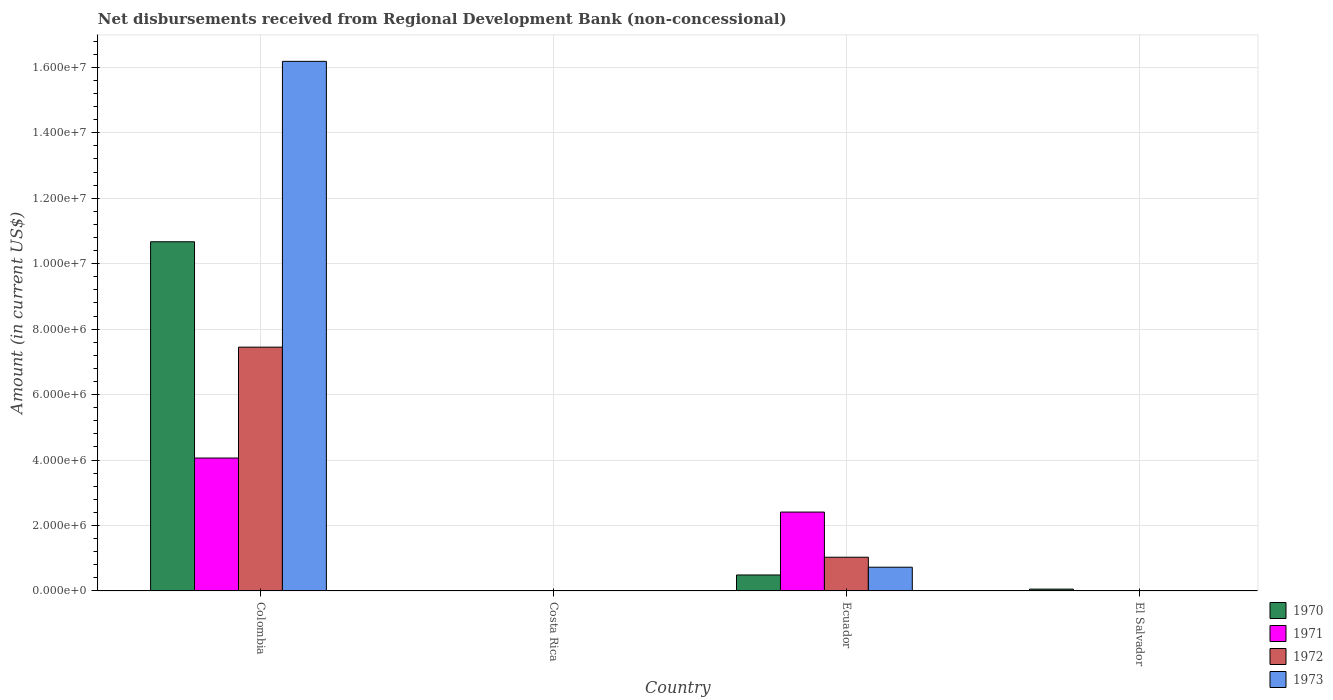How many different coloured bars are there?
Your answer should be compact. 4. Are the number of bars on each tick of the X-axis equal?
Your answer should be very brief. No. How many bars are there on the 4th tick from the left?
Give a very brief answer. 1. In how many cases, is the number of bars for a given country not equal to the number of legend labels?
Ensure brevity in your answer.  2. Across all countries, what is the maximum amount of disbursements received from Regional Development Bank in 1973?
Keep it short and to the point. 1.62e+07. Across all countries, what is the minimum amount of disbursements received from Regional Development Bank in 1973?
Give a very brief answer. 0. What is the total amount of disbursements received from Regional Development Bank in 1971 in the graph?
Offer a very short reply. 6.47e+06. What is the difference between the amount of disbursements received from Regional Development Bank in 1970 in Colombia and that in El Salvador?
Your answer should be compact. 1.06e+07. What is the difference between the amount of disbursements received from Regional Development Bank in 1970 in El Salvador and the amount of disbursements received from Regional Development Bank in 1973 in Costa Rica?
Provide a succinct answer. 5.70e+04. What is the average amount of disbursements received from Regional Development Bank in 1971 per country?
Keep it short and to the point. 1.62e+06. What is the difference between the amount of disbursements received from Regional Development Bank of/in 1970 and amount of disbursements received from Regional Development Bank of/in 1973 in Ecuador?
Your response must be concise. -2.37e+05. Is the amount of disbursements received from Regional Development Bank in 1971 in Colombia less than that in Ecuador?
Offer a very short reply. No. What is the difference between the highest and the second highest amount of disbursements received from Regional Development Bank in 1970?
Your response must be concise. 1.02e+07. What is the difference between the highest and the lowest amount of disbursements received from Regional Development Bank in 1973?
Give a very brief answer. 1.62e+07. In how many countries, is the amount of disbursements received from Regional Development Bank in 1970 greater than the average amount of disbursements received from Regional Development Bank in 1970 taken over all countries?
Provide a succinct answer. 1. Is the sum of the amount of disbursements received from Regional Development Bank in 1972 in Colombia and Ecuador greater than the maximum amount of disbursements received from Regional Development Bank in 1973 across all countries?
Your response must be concise. No. Is it the case that in every country, the sum of the amount of disbursements received from Regional Development Bank in 1973 and amount of disbursements received from Regional Development Bank in 1972 is greater than the amount of disbursements received from Regional Development Bank in 1970?
Your response must be concise. No. How many bars are there?
Your answer should be very brief. 9. Are all the bars in the graph horizontal?
Offer a very short reply. No. Are the values on the major ticks of Y-axis written in scientific E-notation?
Provide a short and direct response. Yes. Does the graph contain grids?
Offer a very short reply. Yes. Where does the legend appear in the graph?
Ensure brevity in your answer.  Bottom right. How many legend labels are there?
Your response must be concise. 4. How are the legend labels stacked?
Offer a terse response. Vertical. What is the title of the graph?
Provide a succinct answer. Net disbursements received from Regional Development Bank (non-concessional). What is the label or title of the X-axis?
Provide a succinct answer. Country. What is the Amount (in current US$) of 1970 in Colombia?
Your answer should be compact. 1.07e+07. What is the Amount (in current US$) of 1971 in Colombia?
Your response must be concise. 4.06e+06. What is the Amount (in current US$) of 1972 in Colombia?
Your answer should be compact. 7.45e+06. What is the Amount (in current US$) of 1973 in Colombia?
Ensure brevity in your answer.  1.62e+07. What is the Amount (in current US$) of 1971 in Costa Rica?
Provide a succinct answer. 0. What is the Amount (in current US$) of 1973 in Costa Rica?
Provide a succinct answer. 0. What is the Amount (in current US$) in 1970 in Ecuador?
Your answer should be very brief. 4.89e+05. What is the Amount (in current US$) in 1971 in Ecuador?
Offer a terse response. 2.41e+06. What is the Amount (in current US$) of 1972 in Ecuador?
Your answer should be very brief. 1.03e+06. What is the Amount (in current US$) of 1973 in Ecuador?
Your answer should be compact. 7.26e+05. What is the Amount (in current US$) in 1970 in El Salvador?
Give a very brief answer. 5.70e+04. What is the Amount (in current US$) in 1972 in El Salvador?
Your answer should be very brief. 0. Across all countries, what is the maximum Amount (in current US$) of 1970?
Offer a terse response. 1.07e+07. Across all countries, what is the maximum Amount (in current US$) in 1971?
Keep it short and to the point. 4.06e+06. Across all countries, what is the maximum Amount (in current US$) of 1972?
Provide a short and direct response. 7.45e+06. Across all countries, what is the maximum Amount (in current US$) in 1973?
Ensure brevity in your answer.  1.62e+07. Across all countries, what is the minimum Amount (in current US$) in 1972?
Offer a terse response. 0. What is the total Amount (in current US$) of 1970 in the graph?
Ensure brevity in your answer.  1.12e+07. What is the total Amount (in current US$) in 1971 in the graph?
Keep it short and to the point. 6.47e+06. What is the total Amount (in current US$) of 1972 in the graph?
Your answer should be compact. 8.48e+06. What is the total Amount (in current US$) of 1973 in the graph?
Your response must be concise. 1.69e+07. What is the difference between the Amount (in current US$) in 1970 in Colombia and that in Ecuador?
Offer a terse response. 1.02e+07. What is the difference between the Amount (in current US$) of 1971 in Colombia and that in Ecuador?
Keep it short and to the point. 1.65e+06. What is the difference between the Amount (in current US$) of 1972 in Colombia and that in Ecuador?
Your answer should be compact. 6.42e+06. What is the difference between the Amount (in current US$) in 1973 in Colombia and that in Ecuador?
Your response must be concise. 1.55e+07. What is the difference between the Amount (in current US$) of 1970 in Colombia and that in El Salvador?
Offer a terse response. 1.06e+07. What is the difference between the Amount (in current US$) of 1970 in Ecuador and that in El Salvador?
Ensure brevity in your answer.  4.32e+05. What is the difference between the Amount (in current US$) in 1970 in Colombia and the Amount (in current US$) in 1971 in Ecuador?
Give a very brief answer. 8.26e+06. What is the difference between the Amount (in current US$) in 1970 in Colombia and the Amount (in current US$) in 1972 in Ecuador?
Ensure brevity in your answer.  9.64e+06. What is the difference between the Amount (in current US$) in 1970 in Colombia and the Amount (in current US$) in 1973 in Ecuador?
Your response must be concise. 9.94e+06. What is the difference between the Amount (in current US$) of 1971 in Colombia and the Amount (in current US$) of 1972 in Ecuador?
Provide a succinct answer. 3.03e+06. What is the difference between the Amount (in current US$) of 1971 in Colombia and the Amount (in current US$) of 1973 in Ecuador?
Offer a very short reply. 3.34e+06. What is the difference between the Amount (in current US$) of 1972 in Colombia and the Amount (in current US$) of 1973 in Ecuador?
Give a very brief answer. 6.72e+06. What is the average Amount (in current US$) of 1970 per country?
Ensure brevity in your answer.  2.80e+06. What is the average Amount (in current US$) in 1971 per country?
Provide a succinct answer. 1.62e+06. What is the average Amount (in current US$) in 1972 per country?
Make the answer very short. 2.12e+06. What is the average Amount (in current US$) of 1973 per country?
Offer a very short reply. 4.23e+06. What is the difference between the Amount (in current US$) in 1970 and Amount (in current US$) in 1971 in Colombia?
Give a very brief answer. 6.61e+06. What is the difference between the Amount (in current US$) of 1970 and Amount (in current US$) of 1972 in Colombia?
Offer a very short reply. 3.22e+06. What is the difference between the Amount (in current US$) in 1970 and Amount (in current US$) in 1973 in Colombia?
Ensure brevity in your answer.  -5.51e+06. What is the difference between the Amount (in current US$) in 1971 and Amount (in current US$) in 1972 in Colombia?
Make the answer very short. -3.39e+06. What is the difference between the Amount (in current US$) of 1971 and Amount (in current US$) of 1973 in Colombia?
Ensure brevity in your answer.  -1.21e+07. What is the difference between the Amount (in current US$) of 1972 and Amount (in current US$) of 1973 in Colombia?
Make the answer very short. -8.73e+06. What is the difference between the Amount (in current US$) of 1970 and Amount (in current US$) of 1971 in Ecuador?
Provide a short and direct response. -1.92e+06. What is the difference between the Amount (in current US$) in 1970 and Amount (in current US$) in 1972 in Ecuador?
Your answer should be very brief. -5.42e+05. What is the difference between the Amount (in current US$) in 1970 and Amount (in current US$) in 1973 in Ecuador?
Your response must be concise. -2.37e+05. What is the difference between the Amount (in current US$) of 1971 and Amount (in current US$) of 1972 in Ecuador?
Give a very brief answer. 1.38e+06. What is the difference between the Amount (in current US$) in 1971 and Amount (in current US$) in 1973 in Ecuador?
Provide a succinct answer. 1.68e+06. What is the difference between the Amount (in current US$) of 1972 and Amount (in current US$) of 1973 in Ecuador?
Offer a terse response. 3.05e+05. What is the ratio of the Amount (in current US$) of 1970 in Colombia to that in Ecuador?
Give a very brief answer. 21.82. What is the ratio of the Amount (in current US$) in 1971 in Colombia to that in Ecuador?
Offer a terse response. 1.68. What is the ratio of the Amount (in current US$) in 1972 in Colombia to that in Ecuador?
Ensure brevity in your answer.  7.23. What is the ratio of the Amount (in current US$) in 1973 in Colombia to that in Ecuador?
Make the answer very short. 22.29. What is the ratio of the Amount (in current US$) in 1970 in Colombia to that in El Salvador?
Offer a terse response. 187.19. What is the ratio of the Amount (in current US$) in 1970 in Ecuador to that in El Salvador?
Provide a succinct answer. 8.58. What is the difference between the highest and the second highest Amount (in current US$) of 1970?
Provide a succinct answer. 1.02e+07. What is the difference between the highest and the lowest Amount (in current US$) of 1970?
Provide a short and direct response. 1.07e+07. What is the difference between the highest and the lowest Amount (in current US$) of 1971?
Offer a terse response. 4.06e+06. What is the difference between the highest and the lowest Amount (in current US$) of 1972?
Provide a short and direct response. 7.45e+06. What is the difference between the highest and the lowest Amount (in current US$) in 1973?
Give a very brief answer. 1.62e+07. 